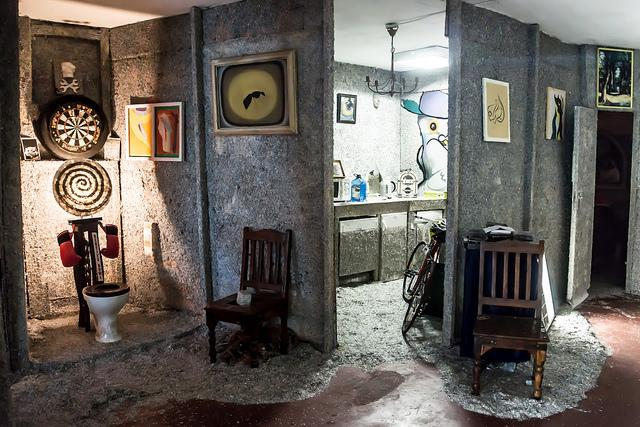Who most likely lives here? Please explain your reasoning. eccentric. There are some really strange things here.  people don't usually keep things like a toilet on display. 